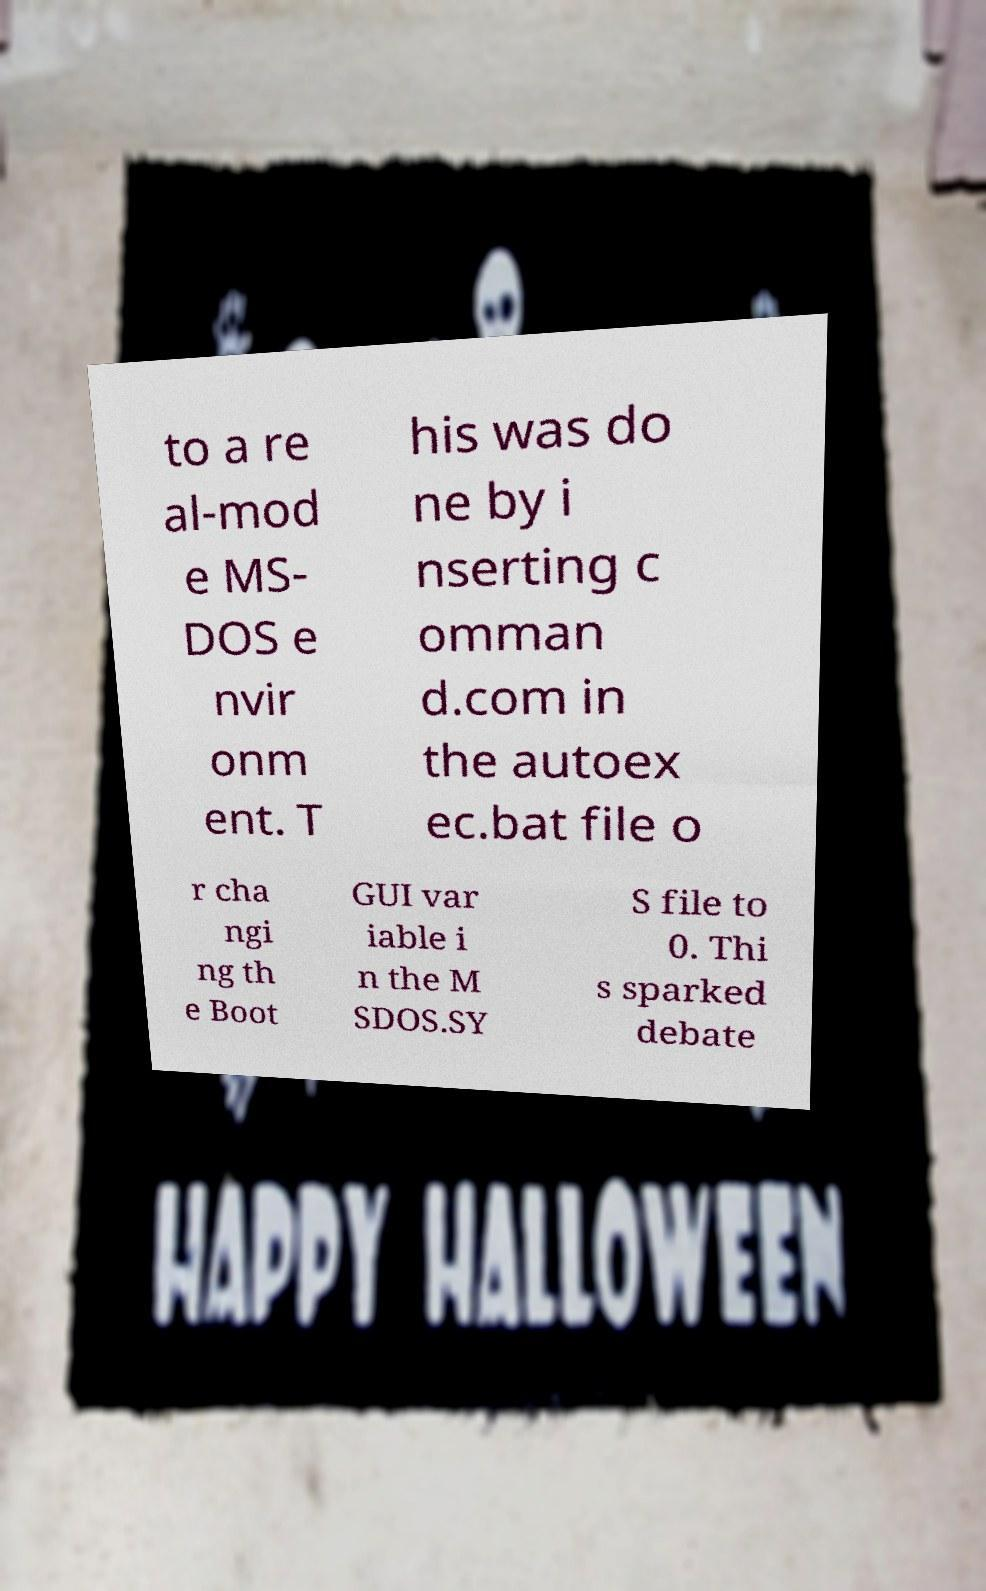For documentation purposes, I need the text within this image transcribed. Could you provide that? to a re al-mod e MS- DOS e nvir onm ent. T his was do ne by i nserting c omman d.com in the autoex ec.bat file o r cha ngi ng th e Boot GUI var iable i n the M SDOS.SY S file to 0. Thi s sparked debate 